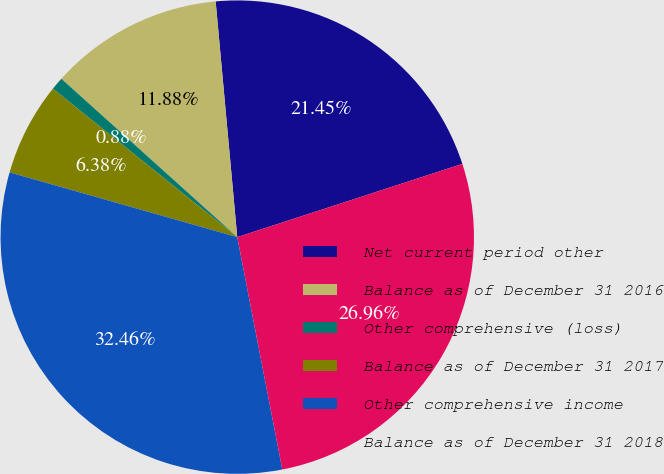<chart> <loc_0><loc_0><loc_500><loc_500><pie_chart><fcel>Net current period other<fcel>Balance as of December 31 2016<fcel>Other comprehensive (loss)<fcel>Balance as of December 31 2017<fcel>Other comprehensive income<fcel>Balance as of December 31 2018<nl><fcel>21.45%<fcel>11.88%<fcel>0.88%<fcel>6.38%<fcel>32.46%<fcel>26.96%<nl></chart> 